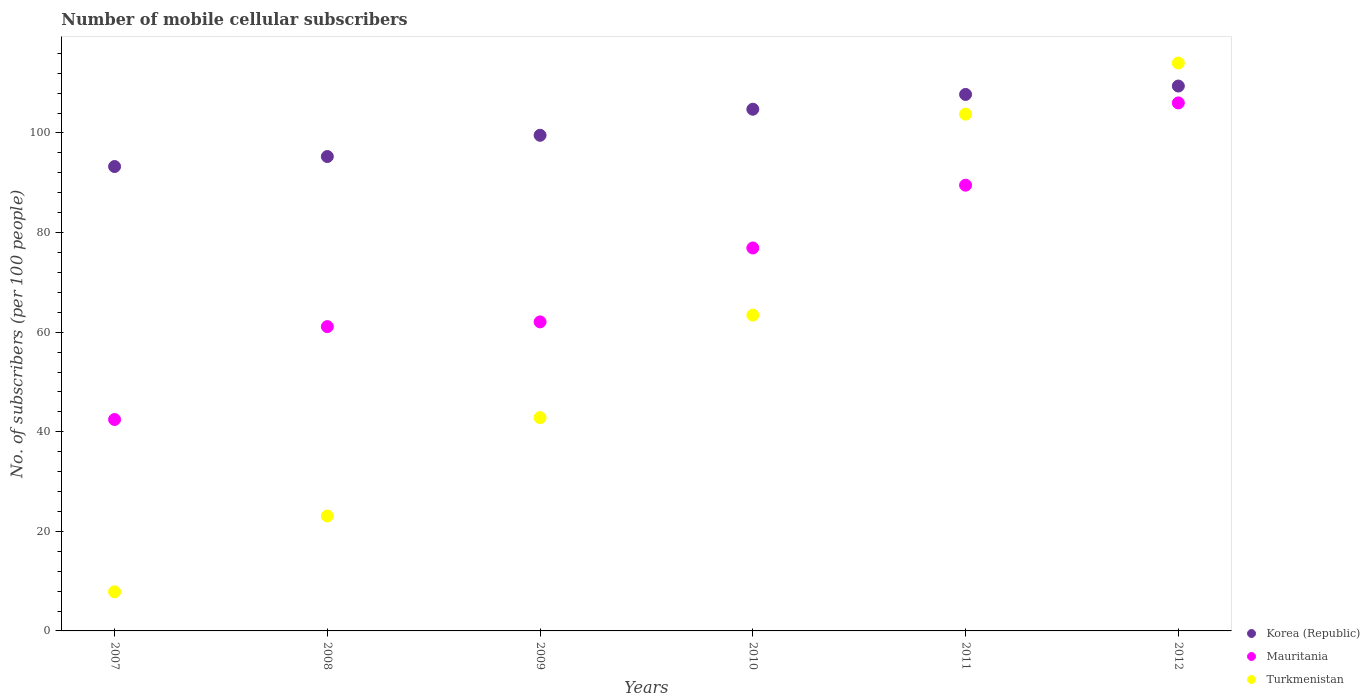Is the number of dotlines equal to the number of legend labels?
Offer a very short reply. Yes. What is the number of mobile cellular subscribers in Mauritania in 2011?
Offer a very short reply. 89.52. Across all years, what is the maximum number of mobile cellular subscribers in Korea (Republic)?
Offer a very short reply. 109.43. Across all years, what is the minimum number of mobile cellular subscribers in Korea (Republic)?
Keep it short and to the point. 93.27. What is the total number of mobile cellular subscribers in Mauritania in the graph?
Ensure brevity in your answer.  438.12. What is the difference between the number of mobile cellular subscribers in Korea (Republic) in 2007 and that in 2010?
Your answer should be compact. -11.51. What is the difference between the number of mobile cellular subscribers in Mauritania in 2009 and the number of mobile cellular subscribers in Korea (Republic) in 2008?
Offer a very short reply. -33.21. What is the average number of mobile cellular subscribers in Korea (Republic) per year?
Your answer should be compact. 101.67. In the year 2010, what is the difference between the number of mobile cellular subscribers in Turkmenistan and number of mobile cellular subscribers in Korea (Republic)?
Your answer should be very brief. -41.35. In how many years, is the number of mobile cellular subscribers in Korea (Republic) greater than 8?
Ensure brevity in your answer.  6. What is the ratio of the number of mobile cellular subscribers in Korea (Republic) in 2009 to that in 2011?
Your answer should be compact. 0.92. Is the number of mobile cellular subscribers in Mauritania in 2008 less than that in 2009?
Provide a short and direct response. Yes. What is the difference between the highest and the second highest number of mobile cellular subscribers in Korea (Republic)?
Offer a terse response. 1.69. What is the difference between the highest and the lowest number of mobile cellular subscribers in Mauritania?
Your response must be concise. 63.58. Does the number of mobile cellular subscribers in Turkmenistan monotonically increase over the years?
Your response must be concise. Yes. Is the number of mobile cellular subscribers in Mauritania strictly greater than the number of mobile cellular subscribers in Korea (Republic) over the years?
Make the answer very short. No. Is the number of mobile cellular subscribers in Korea (Republic) strictly less than the number of mobile cellular subscribers in Turkmenistan over the years?
Make the answer very short. No. How many years are there in the graph?
Ensure brevity in your answer.  6. Does the graph contain any zero values?
Keep it short and to the point. No. How many legend labels are there?
Your response must be concise. 3. What is the title of the graph?
Ensure brevity in your answer.  Number of mobile cellular subscribers. Does "Rwanda" appear as one of the legend labels in the graph?
Keep it short and to the point. No. What is the label or title of the Y-axis?
Your answer should be very brief. No. of subscribers (per 100 people). What is the No. of subscribers (per 100 people) of Korea (Republic) in 2007?
Offer a very short reply. 93.27. What is the No. of subscribers (per 100 people) of Mauritania in 2007?
Your response must be concise. 42.46. What is the No. of subscribers (per 100 people) in Turkmenistan in 2007?
Give a very brief answer. 7.86. What is the No. of subscribers (per 100 people) of Korea (Republic) in 2008?
Provide a short and direct response. 95.28. What is the No. of subscribers (per 100 people) in Mauritania in 2008?
Offer a very short reply. 61.12. What is the No. of subscribers (per 100 people) of Turkmenistan in 2008?
Offer a terse response. 23.08. What is the No. of subscribers (per 100 people) of Korea (Republic) in 2009?
Give a very brief answer. 99.54. What is the No. of subscribers (per 100 people) of Mauritania in 2009?
Offer a terse response. 62.06. What is the No. of subscribers (per 100 people) of Turkmenistan in 2009?
Make the answer very short. 42.84. What is the No. of subscribers (per 100 people) in Korea (Republic) in 2010?
Provide a succinct answer. 104.77. What is the No. of subscribers (per 100 people) in Mauritania in 2010?
Your answer should be very brief. 76.91. What is the No. of subscribers (per 100 people) in Turkmenistan in 2010?
Ensure brevity in your answer.  63.42. What is the No. of subscribers (per 100 people) in Korea (Republic) in 2011?
Give a very brief answer. 107.74. What is the No. of subscribers (per 100 people) of Mauritania in 2011?
Provide a short and direct response. 89.52. What is the No. of subscribers (per 100 people) of Turkmenistan in 2011?
Ensure brevity in your answer.  103.79. What is the No. of subscribers (per 100 people) of Korea (Republic) in 2012?
Your answer should be compact. 109.43. What is the No. of subscribers (per 100 people) in Mauritania in 2012?
Keep it short and to the point. 106.04. What is the No. of subscribers (per 100 people) of Turkmenistan in 2012?
Provide a succinct answer. 114.06. Across all years, what is the maximum No. of subscribers (per 100 people) of Korea (Republic)?
Make the answer very short. 109.43. Across all years, what is the maximum No. of subscribers (per 100 people) in Mauritania?
Keep it short and to the point. 106.04. Across all years, what is the maximum No. of subscribers (per 100 people) in Turkmenistan?
Provide a succinct answer. 114.06. Across all years, what is the minimum No. of subscribers (per 100 people) of Korea (Republic)?
Give a very brief answer. 93.27. Across all years, what is the minimum No. of subscribers (per 100 people) in Mauritania?
Give a very brief answer. 42.46. Across all years, what is the minimum No. of subscribers (per 100 people) of Turkmenistan?
Make the answer very short. 7.86. What is the total No. of subscribers (per 100 people) in Korea (Republic) in the graph?
Make the answer very short. 610.03. What is the total No. of subscribers (per 100 people) of Mauritania in the graph?
Ensure brevity in your answer.  438.12. What is the total No. of subscribers (per 100 people) of Turkmenistan in the graph?
Ensure brevity in your answer.  355.04. What is the difference between the No. of subscribers (per 100 people) of Korea (Republic) in 2007 and that in 2008?
Your answer should be very brief. -2.01. What is the difference between the No. of subscribers (per 100 people) of Mauritania in 2007 and that in 2008?
Give a very brief answer. -18.66. What is the difference between the No. of subscribers (per 100 people) of Turkmenistan in 2007 and that in 2008?
Your answer should be very brief. -15.23. What is the difference between the No. of subscribers (per 100 people) in Korea (Republic) in 2007 and that in 2009?
Your answer should be very brief. -6.28. What is the difference between the No. of subscribers (per 100 people) in Mauritania in 2007 and that in 2009?
Provide a short and direct response. -19.6. What is the difference between the No. of subscribers (per 100 people) in Turkmenistan in 2007 and that in 2009?
Your response must be concise. -34.98. What is the difference between the No. of subscribers (per 100 people) of Korea (Republic) in 2007 and that in 2010?
Offer a terse response. -11.51. What is the difference between the No. of subscribers (per 100 people) in Mauritania in 2007 and that in 2010?
Provide a succinct answer. -34.45. What is the difference between the No. of subscribers (per 100 people) in Turkmenistan in 2007 and that in 2010?
Your response must be concise. -55.56. What is the difference between the No. of subscribers (per 100 people) of Korea (Republic) in 2007 and that in 2011?
Your answer should be compact. -14.48. What is the difference between the No. of subscribers (per 100 people) in Mauritania in 2007 and that in 2011?
Keep it short and to the point. -47.06. What is the difference between the No. of subscribers (per 100 people) in Turkmenistan in 2007 and that in 2011?
Provide a short and direct response. -95.93. What is the difference between the No. of subscribers (per 100 people) of Korea (Republic) in 2007 and that in 2012?
Offer a very short reply. -16.17. What is the difference between the No. of subscribers (per 100 people) in Mauritania in 2007 and that in 2012?
Provide a succinct answer. -63.58. What is the difference between the No. of subscribers (per 100 people) in Turkmenistan in 2007 and that in 2012?
Offer a terse response. -106.2. What is the difference between the No. of subscribers (per 100 people) of Korea (Republic) in 2008 and that in 2009?
Provide a succinct answer. -4.27. What is the difference between the No. of subscribers (per 100 people) in Mauritania in 2008 and that in 2009?
Your answer should be compact. -0.95. What is the difference between the No. of subscribers (per 100 people) of Turkmenistan in 2008 and that in 2009?
Ensure brevity in your answer.  -19.75. What is the difference between the No. of subscribers (per 100 people) of Korea (Republic) in 2008 and that in 2010?
Your answer should be very brief. -9.5. What is the difference between the No. of subscribers (per 100 people) of Mauritania in 2008 and that in 2010?
Keep it short and to the point. -15.79. What is the difference between the No. of subscribers (per 100 people) in Turkmenistan in 2008 and that in 2010?
Ensure brevity in your answer.  -40.34. What is the difference between the No. of subscribers (per 100 people) in Korea (Republic) in 2008 and that in 2011?
Provide a short and direct response. -12.47. What is the difference between the No. of subscribers (per 100 people) in Mauritania in 2008 and that in 2011?
Offer a terse response. -28.4. What is the difference between the No. of subscribers (per 100 people) in Turkmenistan in 2008 and that in 2011?
Ensure brevity in your answer.  -80.7. What is the difference between the No. of subscribers (per 100 people) in Korea (Republic) in 2008 and that in 2012?
Make the answer very short. -14.15. What is the difference between the No. of subscribers (per 100 people) of Mauritania in 2008 and that in 2012?
Your answer should be very brief. -44.92. What is the difference between the No. of subscribers (per 100 people) in Turkmenistan in 2008 and that in 2012?
Give a very brief answer. -90.97. What is the difference between the No. of subscribers (per 100 people) of Korea (Republic) in 2009 and that in 2010?
Offer a terse response. -5.23. What is the difference between the No. of subscribers (per 100 people) in Mauritania in 2009 and that in 2010?
Give a very brief answer. -14.85. What is the difference between the No. of subscribers (per 100 people) in Turkmenistan in 2009 and that in 2010?
Make the answer very short. -20.58. What is the difference between the No. of subscribers (per 100 people) of Korea (Republic) in 2009 and that in 2011?
Your response must be concise. -8.2. What is the difference between the No. of subscribers (per 100 people) of Mauritania in 2009 and that in 2011?
Your answer should be compact. -27.46. What is the difference between the No. of subscribers (per 100 people) in Turkmenistan in 2009 and that in 2011?
Your answer should be compact. -60.95. What is the difference between the No. of subscribers (per 100 people) of Korea (Republic) in 2009 and that in 2012?
Your response must be concise. -9.89. What is the difference between the No. of subscribers (per 100 people) of Mauritania in 2009 and that in 2012?
Your answer should be very brief. -43.98. What is the difference between the No. of subscribers (per 100 people) in Turkmenistan in 2009 and that in 2012?
Offer a terse response. -71.22. What is the difference between the No. of subscribers (per 100 people) in Korea (Republic) in 2010 and that in 2011?
Make the answer very short. -2.97. What is the difference between the No. of subscribers (per 100 people) of Mauritania in 2010 and that in 2011?
Offer a very short reply. -12.61. What is the difference between the No. of subscribers (per 100 people) in Turkmenistan in 2010 and that in 2011?
Offer a terse response. -40.37. What is the difference between the No. of subscribers (per 100 people) of Korea (Republic) in 2010 and that in 2012?
Provide a short and direct response. -4.66. What is the difference between the No. of subscribers (per 100 people) of Mauritania in 2010 and that in 2012?
Give a very brief answer. -29.13. What is the difference between the No. of subscribers (per 100 people) in Turkmenistan in 2010 and that in 2012?
Give a very brief answer. -50.64. What is the difference between the No. of subscribers (per 100 people) of Korea (Republic) in 2011 and that in 2012?
Your answer should be compact. -1.69. What is the difference between the No. of subscribers (per 100 people) of Mauritania in 2011 and that in 2012?
Make the answer very short. -16.52. What is the difference between the No. of subscribers (per 100 people) in Turkmenistan in 2011 and that in 2012?
Keep it short and to the point. -10.27. What is the difference between the No. of subscribers (per 100 people) of Korea (Republic) in 2007 and the No. of subscribers (per 100 people) of Mauritania in 2008?
Ensure brevity in your answer.  32.15. What is the difference between the No. of subscribers (per 100 people) of Korea (Republic) in 2007 and the No. of subscribers (per 100 people) of Turkmenistan in 2008?
Make the answer very short. 70.18. What is the difference between the No. of subscribers (per 100 people) of Mauritania in 2007 and the No. of subscribers (per 100 people) of Turkmenistan in 2008?
Make the answer very short. 19.38. What is the difference between the No. of subscribers (per 100 people) in Korea (Republic) in 2007 and the No. of subscribers (per 100 people) in Mauritania in 2009?
Provide a succinct answer. 31.2. What is the difference between the No. of subscribers (per 100 people) of Korea (Republic) in 2007 and the No. of subscribers (per 100 people) of Turkmenistan in 2009?
Make the answer very short. 50.43. What is the difference between the No. of subscribers (per 100 people) in Mauritania in 2007 and the No. of subscribers (per 100 people) in Turkmenistan in 2009?
Offer a very short reply. -0.38. What is the difference between the No. of subscribers (per 100 people) in Korea (Republic) in 2007 and the No. of subscribers (per 100 people) in Mauritania in 2010?
Make the answer very short. 16.36. What is the difference between the No. of subscribers (per 100 people) of Korea (Republic) in 2007 and the No. of subscribers (per 100 people) of Turkmenistan in 2010?
Your response must be concise. 29.85. What is the difference between the No. of subscribers (per 100 people) of Mauritania in 2007 and the No. of subscribers (per 100 people) of Turkmenistan in 2010?
Offer a terse response. -20.96. What is the difference between the No. of subscribers (per 100 people) in Korea (Republic) in 2007 and the No. of subscribers (per 100 people) in Mauritania in 2011?
Provide a short and direct response. 3.74. What is the difference between the No. of subscribers (per 100 people) of Korea (Republic) in 2007 and the No. of subscribers (per 100 people) of Turkmenistan in 2011?
Your answer should be compact. -10.52. What is the difference between the No. of subscribers (per 100 people) in Mauritania in 2007 and the No. of subscribers (per 100 people) in Turkmenistan in 2011?
Provide a succinct answer. -61.32. What is the difference between the No. of subscribers (per 100 people) in Korea (Republic) in 2007 and the No. of subscribers (per 100 people) in Mauritania in 2012?
Your answer should be compact. -12.78. What is the difference between the No. of subscribers (per 100 people) of Korea (Republic) in 2007 and the No. of subscribers (per 100 people) of Turkmenistan in 2012?
Your answer should be compact. -20.79. What is the difference between the No. of subscribers (per 100 people) in Mauritania in 2007 and the No. of subscribers (per 100 people) in Turkmenistan in 2012?
Make the answer very short. -71.59. What is the difference between the No. of subscribers (per 100 people) in Korea (Republic) in 2008 and the No. of subscribers (per 100 people) in Mauritania in 2009?
Give a very brief answer. 33.21. What is the difference between the No. of subscribers (per 100 people) in Korea (Republic) in 2008 and the No. of subscribers (per 100 people) in Turkmenistan in 2009?
Provide a short and direct response. 52.44. What is the difference between the No. of subscribers (per 100 people) in Mauritania in 2008 and the No. of subscribers (per 100 people) in Turkmenistan in 2009?
Make the answer very short. 18.28. What is the difference between the No. of subscribers (per 100 people) of Korea (Republic) in 2008 and the No. of subscribers (per 100 people) of Mauritania in 2010?
Your response must be concise. 18.37. What is the difference between the No. of subscribers (per 100 people) of Korea (Republic) in 2008 and the No. of subscribers (per 100 people) of Turkmenistan in 2010?
Give a very brief answer. 31.86. What is the difference between the No. of subscribers (per 100 people) in Mauritania in 2008 and the No. of subscribers (per 100 people) in Turkmenistan in 2010?
Give a very brief answer. -2.3. What is the difference between the No. of subscribers (per 100 people) of Korea (Republic) in 2008 and the No. of subscribers (per 100 people) of Mauritania in 2011?
Provide a succinct answer. 5.76. What is the difference between the No. of subscribers (per 100 people) of Korea (Republic) in 2008 and the No. of subscribers (per 100 people) of Turkmenistan in 2011?
Your response must be concise. -8.51. What is the difference between the No. of subscribers (per 100 people) of Mauritania in 2008 and the No. of subscribers (per 100 people) of Turkmenistan in 2011?
Ensure brevity in your answer.  -42.67. What is the difference between the No. of subscribers (per 100 people) in Korea (Republic) in 2008 and the No. of subscribers (per 100 people) in Mauritania in 2012?
Your answer should be compact. -10.76. What is the difference between the No. of subscribers (per 100 people) in Korea (Republic) in 2008 and the No. of subscribers (per 100 people) in Turkmenistan in 2012?
Give a very brief answer. -18.78. What is the difference between the No. of subscribers (per 100 people) of Mauritania in 2008 and the No. of subscribers (per 100 people) of Turkmenistan in 2012?
Your response must be concise. -52.94. What is the difference between the No. of subscribers (per 100 people) of Korea (Republic) in 2009 and the No. of subscribers (per 100 people) of Mauritania in 2010?
Provide a succinct answer. 22.63. What is the difference between the No. of subscribers (per 100 people) in Korea (Republic) in 2009 and the No. of subscribers (per 100 people) in Turkmenistan in 2010?
Your response must be concise. 36.12. What is the difference between the No. of subscribers (per 100 people) of Mauritania in 2009 and the No. of subscribers (per 100 people) of Turkmenistan in 2010?
Your response must be concise. -1.35. What is the difference between the No. of subscribers (per 100 people) of Korea (Republic) in 2009 and the No. of subscribers (per 100 people) of Mauritania in 2011?
Provide a succinct answer. 10.02. What is the difference between the No. of subscribers (per 100 people) of Korea (Republic) in 2009 and the No. of subscribers (per 100 people) of Turkmenistan in 2011?
Give a very brief answer. -4.24. What is the difference between the No. of subscribers (per 100 people) in Mauritania in 2009 and the No. of subscribers (per 100 people) in Turkmenistan in 2011?
Provide a succinct answer. -41.72. What is the difference between the No. of subscribers (per 100 people) of Korea (Republic) in 2009 and the No. of subscribers (per 100 people) of Mauritania in 2012?
Offer a very short reply. -6.5. What is the difference between the No. of subscribers (per 100 people) of Korea (Republic) in 2009 and the No. of subscribers (per 100 people) of Turkmenistan in 2012?
Give a very brief answer. -14.51. What is the difference between the No. of subscribers (per 100 people) in Mauritania in 2009 and the No. of subscribers (per 100 people) in Turkmenistan in 2012?
Your answer should be compact. -51.99. What is the difference between the No. of subscribers (per 100 people) of Korea (Republic) in 2010 and the No. of subscribers (per 100 people) of Mauritania in 2011?
Your answer should be very brief. 15.25. What is the difference between the No. of subscribers (per 100 people) of Korea (Republic) in 2010 and the No. of subscribers (per 100 people) of Turkmenistan in 2011?
Your answer should be very brief. 0.99. What is the difference between the No. of subscribers (per 100 people) of Mauritania in 2010 and the No. of subscribers (per 100 people) of Turkmenistan in 2011?
Your answer should be compact. -26.87. What is the difference between the No. of subscribers (per 100 people) of Korea (Republic) in 2010 and the No. of subscribers (per 100 people) of Mauritania in 2012?
Make the answer very short. -1.27. What is the difference between the No. of subscribers (per 100 people) in Korea (Republic) in 2010 and the No. of subscribers (per 100 people) in Turkmenistan in 2012?
Offer a very short reply. -9.28. What is the difference between the No. of subscribers (per 100 people) of Mauritania in 2010 and the No. of subscribers (per 100 people) of Turkmenistan in 2012?
Ensure brevity in your answer.  -37.14. What is the difference between the No. of subscribers (per 100 people) in Korea (Republic) in 2011 and the No. of subscribers (per 100 people) in Mauritania in 2012?
Your answer should be compact. 1.7. What is the difference between the No. of subscribers (per 100 people) in Korea (Republic) in 2011 and the No. of subscribers (per 100 people) in Turkmenistan in 2012?
Your answer should be compact. -6.31. What is the difference between the No. of subscribers (per 100 people) in Mauritania in 2011 and the No. of subscribers (per 100 people) in Turkmenistan in 2012?
Your answer should be very brief. -24.53. What is the average No. of subscribers (per 100 people) of Korea (Republic) per year?
Your answer should be compact. 101.67. What is the average No. of subscribers (per 100 people) in Mauritania per year?
Ensure brevity in your answer.  73.02. What is the average No. of subscribers (per 100 people) of Turkmenistan per year?
Keep it short and to the point. 59.17. In the year 2007, what is the difference between the No. of subscribers (per 100 people) of Korea (Republic) and No. of subscribers (per 100 people) of Mauritania?
Provide a short and direct response. 50.81. In the year 2007, what is the difference between the No. of subscribers (per 100 people) in Korea (Republic) and No. of subscribers (per 100 people) in Turkmenistan?
Make the answer very short. 85.41. In the year 2007, what is the difference between the No. of subscribers (per 100 people) of Mauritania and No. of subscribers (per 100 people) of Turkmenistan?
Provide a succinct answer. 34.6. In the year 2008, what is the difference between the No. of subscribers (per 100 people) in Korea (Republic) and No. of subscribers (per 100 people) in Mauritania?
Your response must be concise. 34.16. In the year 2008, what is the difference between the No. of subscribers (per 100 people) of Korea (Republic) and No. of subscribers (per 100 people) of Turkmenistan?
Make the answer very short. 72.19. In the year 2008, what is the difference between the No. of subscribers (per 100 people) of Mauritania and No. of subscribers (per 100 people) of Turkmenistan?
Offer a terse response. 38.03. In the year 2009, what is the difference between the No. of subscribers (per 100 people) of Korea (Republic) and No. of subscribers (per 100 people) of Mauritania?
Offer a terse response. 37.48. In the year 2009, what is the difference between the No. of subscribers (per 100 people) in Korea (Republic) and No. of subscribers (per 100 people) in Turkmenistan?
Your answer should be very brief. 56.7. In the year 2009, what is the difference between the No. of subscribers (per 100 people) in Mauritania and No. of subscribers (per 100 people) in Turkmenistan?
Provide a succinct answer. 19.23. In the year 2010, what is the difference between the No. of subscribers (per 100 people) of Korea (Republic) and No. of subscribers (per 100 people) of Mauritania?
Offer a terse response. 27.86. In the year 2010, what is the difference between the No. of subscribers (per 100 people) of Korea (Republic) and No. of subscribers (per 100 people) of Turkmenistan?
Keep it short and to the point. 41.35. In the year 2010, what is the difference between the No. of subscribers (per 100 people) in Mauritania and No. of subscribers (per 100 people) in Turkmenistan?
Give a very brief answer. 13.49. In the year 2011, what is the difference between the No. of subscribers (per 100 people) of Korea (Republic) and No. of subscribers (per 100 people) of Mauritania?
Keep it short and to the point. 18.22. In the year 2011, what is the difference between the No. of subscribers (per 100 people) of Korea (Republic) and No. of subscribers (per 100 people) of Turkmenistan?
Offer a very short reply. 3.96. In the year 2011, what is the difference between the No. of subscribers (per 100 people) in Mauritania and No. of subscribers (per 100 people) in Turkmenistan?
Make the answer very short. -14.26. In the year 2012, what is the difference between the No. of subscribers (per 100 people) in Korea (Republic) and No. of subscribers (per 100 people) in Mauritania?
Offer a terse response. 3.39. In the year 2012, what is the difference between the No. of subscribers (per 100 people) in Korea (Republic) and No. of subscribers (per 100 people) in Turkmenistan?
Make the answer very short. -4.62. In the year 2012, what is the difference between the No. of subscribers (per 100 people) in Mauritania and No. of subscribers (per 100 people) in Turkmenistan?
Offer a terse response. -8.01. What is the ratio of the No. of subscribers (per 100 people) in Korea (Republic) in 2007 to that in 2008?
Keep it short and to the point. 0.98. What is the ratio of the No. of subscribers (per 100 people) of Mauritania in 2007 to that in 2008?
Give a very brief answer. 0.69. What is the ratio of the No. of subscribers (per 100 people) of Turkmenistan in 2007 to that in 2008?
Your answer should be compact. 0.34. What is the ratio of the No. of subscribers (per 100 people) of Korea (Republic) in 2007 to that in 2009?
Make the answer very short. 0.94. What is the ratio of the No. of subscribers (per 100 people) of Mauritania in 2007 to that in 2009?
Provide a short and direct response. 0.68. What is the ratio of the No. of subscribers (per 100 people) in Turkmenistan in 2007 to that in 2009?
Ensure brevity in your answer.  0.18. What is the ratio of the No. of subscribers (per 100 people) in Korea (Republic) in 2007 to that in 2010?
Your answer should be compact. 0.89. What is the ratio of the No. of subscribers (per 100 people) in Mauritania in 2007 to that in 2010?
Keep it short and to the point. 0.55. What is the ratio of the No. of subscribers (per 100 people) in Turkmenistan in 2007 to that in 2010?
Offer a very short reply. 0.12. What is the ratio of the No. of subscribers (per 100 people) of Korea (Republic) in 2007 to that in 2011?
Offer a very short reply. 0.87. What is the ratio of the No. of subscribers (per 100 people) of Mauritania in 2007 to that in 2011?
Offer a very short reply. 0.47. What is the ratio of the No. of subscribers (per 100 people) in Turkmenistan in 2007 to that in 2011?
Give a very brief answer. 0.08. What is the ratio of the No. of subscribers (per 100 people) of Korea (Republic) in 2007 to that in 2012?
Provide a short and direct response. 0.85. What is the ratio of the No. of subscribers (per 100 people) of Mauritania in 2007 to that in 2012?
Provide a short and direct response. 0.4. What is the ratio of the No. of subscribers (per 100 people) of Turkmenistan in 2007 to that in 2012?
Your response must be concise. 0.07. What is the ratio of the No. of subscribers (per 100 people) in Korea (Republic) in 2008 to that in 2009?
Provide a succinct answer. 0.96. What is the ratio of the No. of subscribers (per 100 people) in Mauritania in 2008 to that in 2009?
Offer a very short reply. 0.98. What is the ratio of the No. of subscribers (per 100 people) of Turkmenistan in 2008 to that in 2009?
Keep it short and to the point. 0.54. What is the ratio of the No. of subscribers (per 100 people) of Korea (Republic) in 2008 to that in 2010?
Offer a terse response. 0.91. What is the ratio of the No. of subscribers (per 100 people) of Mauritania in 2008 to that in 2010?
Give a very brief answer. 0.79. What is the ratio of the No. of subscribers (per 100 people) of Turkmenistan in 2008 to that in 2010?
Make the answer very short. 0.36. What is the ratio of the No. of subscribers (per 100 people) in Korea (Republic) in 2008 to that in 2011?
Offer a terse response. 0.88. What is the ratio of the No. of subscribers (per 100 people) of Mauritania in 2008 to that in 2011?
Your answer should be very brief. 0.68. What is the ratio of the No. of subscribers (per 100 people) in Turkmenistan in 2008 to that in 2011?
Provide a short and direct response. 0.22. What is the ratio of the No. of subscribers (per 100 people) of Korea (Republic) in 2008 to that in 2012?
Provide a succinct answer. 0.87. What is the ratio of the No. of subscribers (per 100 people) of Mauritania in 2008 to that in 2012?
Provide a short and direct response. 0.58. What is the ratio of the No. of subscribers (per 100 people) of Turkmenistan in 2008 to that in 2012?
Your response must be concise. 0.2. What is the ratio of the No. of subscribers (per 100 people) of Korea (Republic) in 2009 to that in 2010?
Your answer should be very brief. 0.95. What is the ratio of the No. of subscribers (per 100 people) of Mauritania in 2009 to that in 2010?
Your answer should be very brief. 0.81. What is the ratio of the No. of subscribers (per 100 people) in Turkmenistan in 2009 to that in 2010?
Your answer should be compact. 0.68. What is the ratio of the No. of subscribers (per 100 people) of Korea (Republic) in 2009 to that in 2011?
Give a very brief answer. 0.92. What is the ratio of the No. of subscribers (per 100 people) of Mauritania in 2009 to that in 2011?
Ensure brevity in your answer.  0.69. What is the ratio of the No. of subscribers (per 100 people) in Turkmenistan in 2009 to that in 2011?
Your answer should be very brief. 0.41. What is the ratio of the No. of subscribers (per 100 people) of Korea (Republic) in 2009 to that in 2012?
Your answer should be compact. 0.91. What is the ratio of the No. of subscribers (per 100 people) of Mauritania in 2009 to that in 2012?
Your response must be concise. 0.59. What is the ratio of the No. of subscribers (per 100 people) of Turkmenistan in 2009 to that in 2012?
Ensure brevity in your answer.  0.38. What is the ratio of the No. of subscribers (per 100 people) in Korea (Republic) in 2010 to that in 2011?
Provide a succinct answer. 0.97. What is the ratio of the No. of subscribers (per 100 people) of Mauritania in 2010 to that in 2011?
Your answer should be very brief. 0.86. What is the ratio of the No. of subscribers (per 100 people) in Turkmenistan in 2010 to that in 2011?
Keep it short and to the point. 0.61. What is the ratio of the No. of subscribers (per 100 people) in Korea (Republic) in 2010 to that in 2012?
Ensure brevity in your answer.  0.96. What is the ratio of the No. of subscribers (per 100 people) of Mauritania in 2010 to that in 2012?
Give a very brief answer. 0.73. What is the ratio of the No. of subscribers (per 100 people) in Turkmenistan in 2010 to that in 2012?
Provide a short and direct response. 0.56. What is the ratio of the No. of subscribers (per 100 people) of Korea (Republic) in 2011 to that in 2012?
Provide a succinct answer. 0.98. What is the ratio of the No. of subscribers (per 100 people) in Mauritania in 2011 to that in 2012?
Provide a succinct answer. 0.84. What is the ratio of the No. of subscribers (per 100 people) in Turkmenistan in 2011 to that in 2012?
Provide a succinct answer. 0.91. What is the difference between the highest and the second highest No. of subscribers (per 100 people) of Korea (Republic)?
Offer a very short reply. 1.69. What is the difference between the highest and the second highest No. of subscribers (per 100 people) of Mauritania?
Your response must be concise. 16.52. What is the difference between the highest and the second highest No. of subscribers (per 100 people) of Turkmenistan?
Your response must be concise. 10.27. What is the difference between the highest and the lowest No. of subscribers (per 100 people) in Korea (Republic)?
Give a very brief answer. 16.17. What is the difference between the highest and the lowest No. of subscribers (per 100 people) in Mauritania?
Make the answer very short. 63.58. What is the difference between the highest and the lowest No. of subscribers (per 100 people) in Turkmenistan?
Provide a succinct answer. 106.2. 